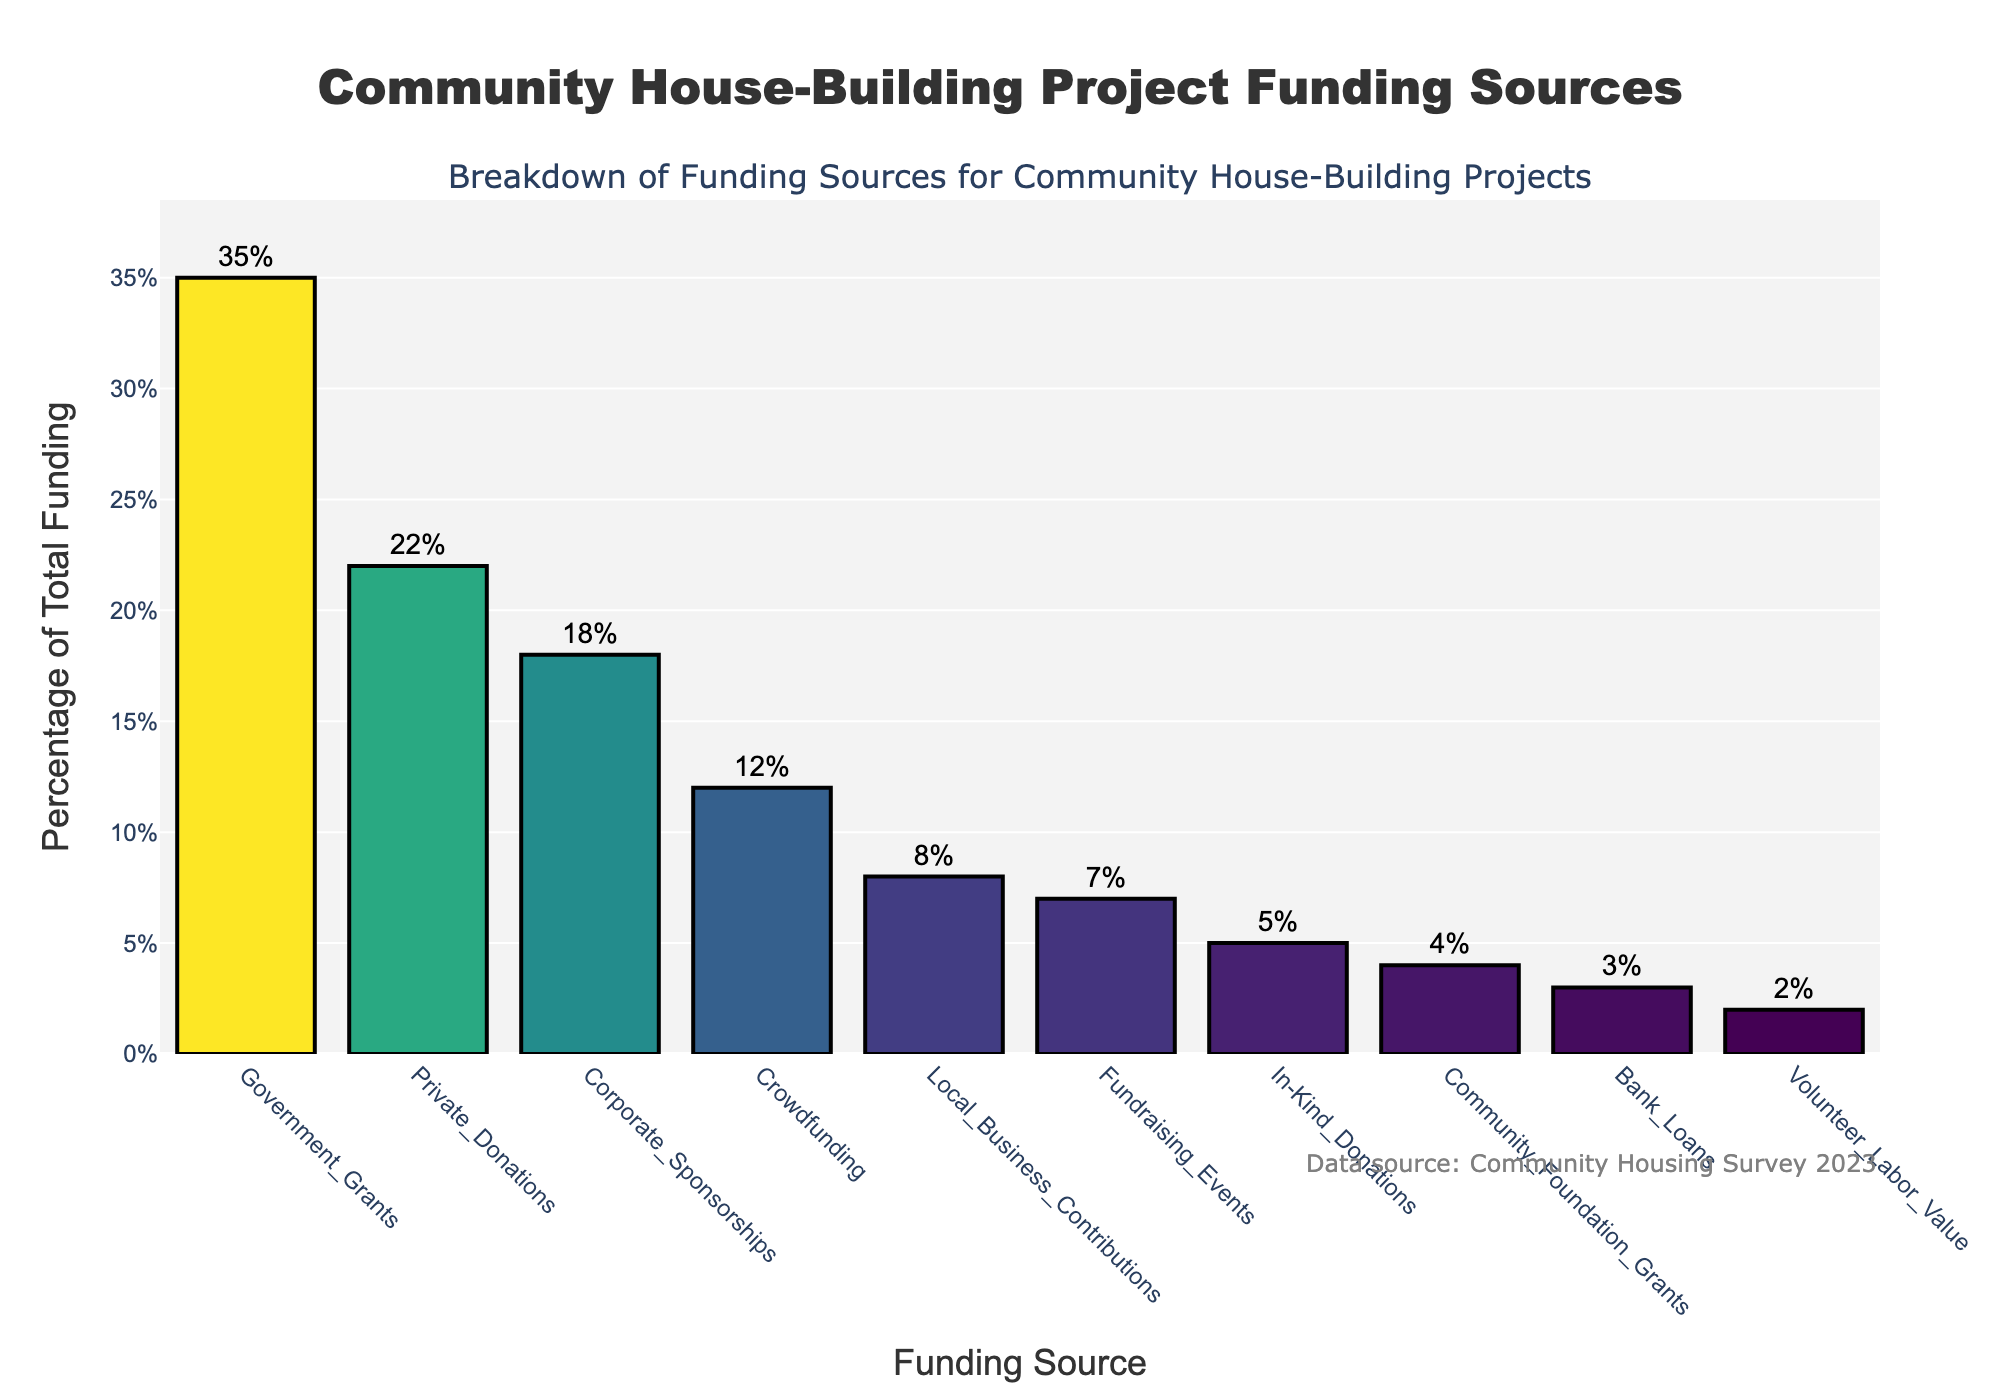what is the highest funding source percentage? The bar representing government grants is the tallest in the chart, indicating the highest percentage. The label shows 35%.
Answer: 35% What is the combined percentage of private donations and corporate sponsorships? The percentage for private donations is 22% and for corporate sponsorships is 18%. Adding these gives 22% + 18% = 40%.
Answer: 40% Are there more funding sources above 10% or below 10%? Looking at the chart, we see four funding sources above 10% (Government Grants, Private Donations, Corporate Sponsorships, Crowdfunding) and six funding sources below 10%. Therefore, there are more below 10%.
Answer: Below 10% What's the difference between the highest and lowest funding source percentages? The highest funding source percentage is for government grants (35%), and the lowest is volunteer labor value (2%). The difference is 35% - 2% = 33%.
Answer: 33% Is the percentage of local business contributions greater than or less than the percentage of community foundation grants? The percentage for local business contributions is 8%, and for community foundation grants, it is 4%. Therefore, local business contributions are greater.
Answer: Greater What's the average percentage of the funding sources? Sum all percentages: 35 + 22 + 18 + 12 + 8 + 7 + 5 + 4 + 3 + 2 = 116. There are 10 funding sources, so the average is 116/10 = 11.6%.
Answer: 11.6% Which funding source contributes the least to the overall funding? The shortest bar on the chart represents volunteer labor value, which contributes 2%.
Answer: Volunteer Labor Value What is the median funding source percentage? When sorted in ascending order, the percentages are 2, 3, 4, 5, 7, 8, 12, 18, 22, 35. The median is the average of the fifth and sixth values, (7 + 8) / 2 = 7.5%.
Answer: 7.5% How much higher is the percentage for government grants compared to crowdfunding? Government grants have 35% and crowdfunding has 12%. The difference is 35% - 12% = 23%.
Answer: 23% Which funding source has a percentage closest to 10%? Crowdfunding has a percentage of 12%, which is closest to 10% compared to other funding sources on the chart.
Answer: Crowdfunding 